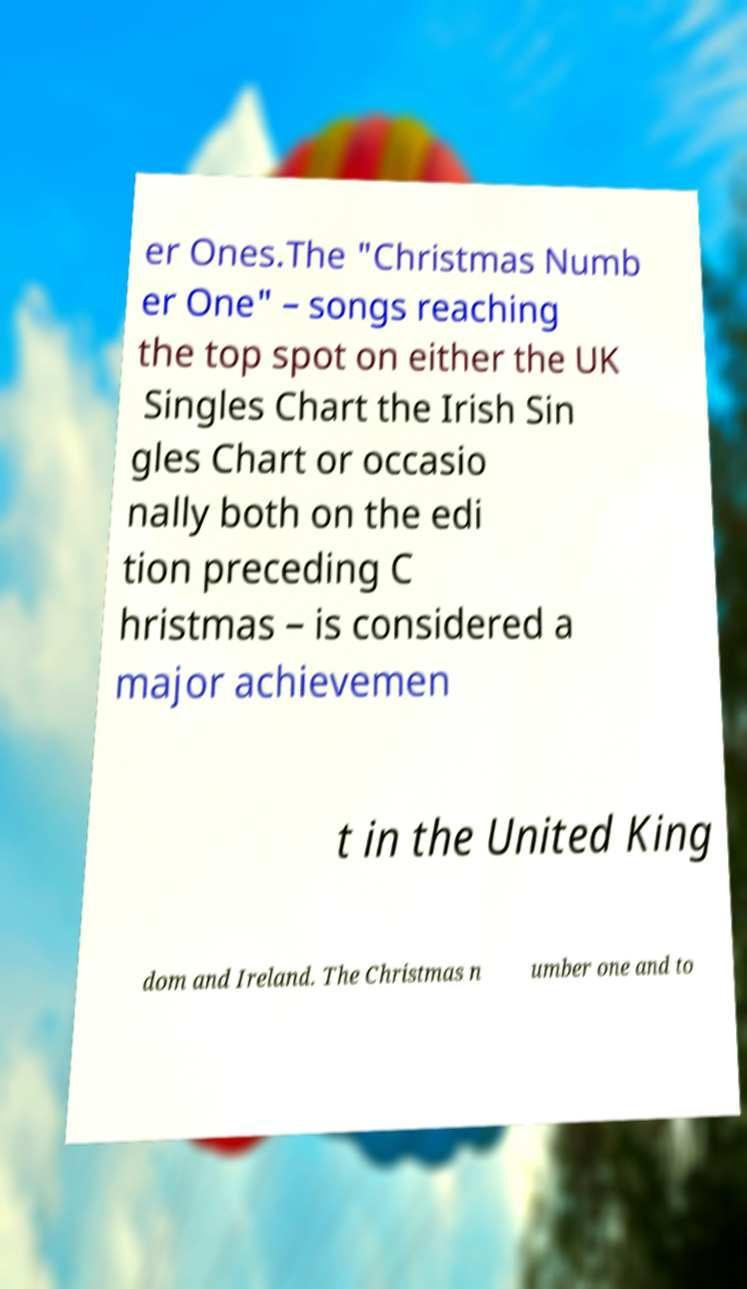There's text embedded in this image that I need extracted. Can you transcribe it verbatim? er Ones.The "Christmas Numb er One" – songs reaching the top spot on either the UK Singles Chart the Irish Sin gles Chart or occasio nally both on the edi tion preceding C hristmas – is considered a major achievemen t in the United King dom and Ireland. The Christmas n umber one and to 